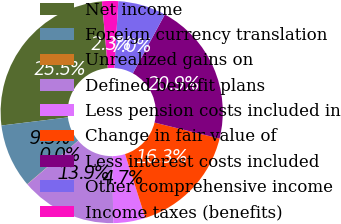Convert chart to OTSL. <chart><loc_0><loc_0><loc_500><loc_500><pie_chart><fcel>Net income<fcel>Foreign currency translation<fcel>Unrealized gains on<fcel>Defined benefit plans<fcel>Less pension costs included in<fcel>Change in fair value of<fcel>Less interest costs included<fcel>Other comprehensive income<fcel>Income taxes (benefits)<nl><fcel>25.54%<fcel>9.31%<fcel>0.03%<fcel>13.95%<fcel>4.67%<fcel>16.27%<fcel>20.9%<fcel>6.99%<fcel>2.35%<nl></chart> 